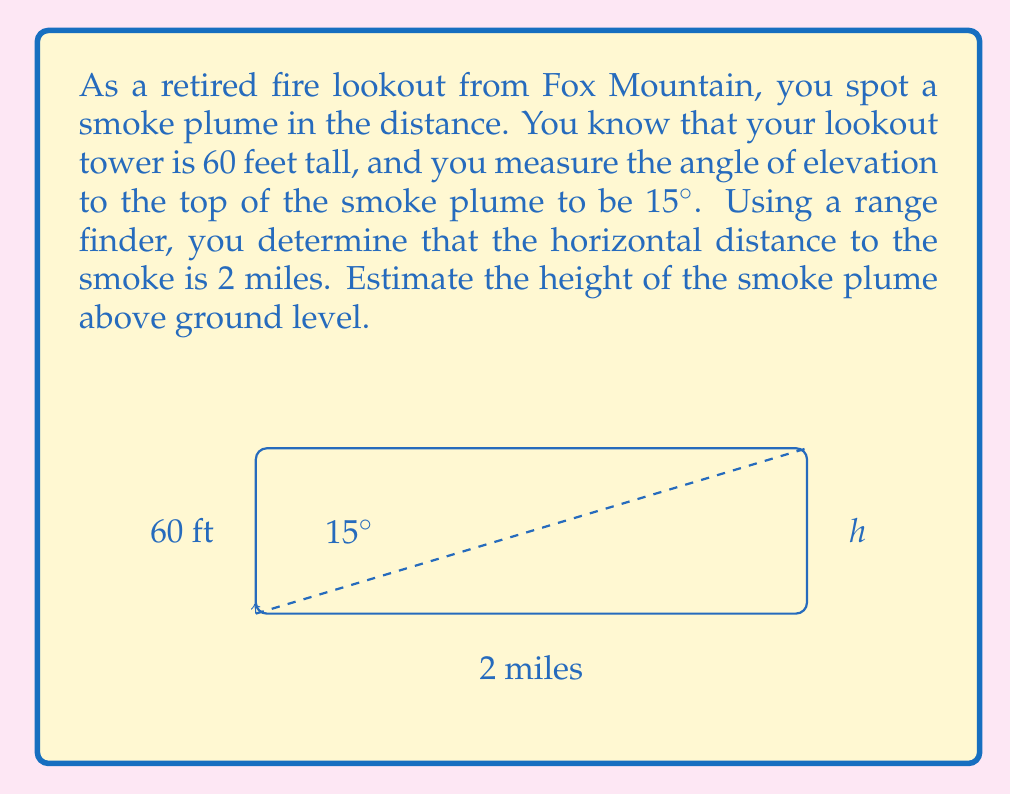Solve this math problem. Let's approach this step-by-step using similar triangles:

1) First, we need to convert 2 miles to feet:
   $2 \text{ miles} = 2 \times 5280 = 10560 \text{ feet}$

2) Now, let's set up our similar triangles. We have:
   - The small triangle: height of the tower (60 ft) and its shadow
   - The large triangle: height of the smoke plume (h) and the distance to it (10560 ft)

3) The tangent of 15° is the ratio of the opposite side to the adjacent side in both triangles:

   $$\tan 15° = \frac{60}{x} = \frac{h}{10560}$$

   Where $x$ is the length of the tower's shadow, and $h$ is the height of the smoke plume.

4) We can calculate $\tan 15°$:
   $$\tan 15° \approx 0.2679$$

5) Now we can solve for $h$:

   $$0.2679 = \frac{h}{10560}$$
   $$h = 0.2679 \times 10560 = 2829.02 \text{ feet}$$

6) However, this is the height above your eye level. To get the height above ground level, we need to add the height of the tower:

   $$h_{total} = 2829.02 + 60 = 2889.02 \text{ feet}$$

7) Rounding to a reasonable precision for an estimate:

   $$h_{total} \approx 2890 \text{ feet}$$
Answer: The estimated height of the smoke plume is approximately 2890 feet above ground level. 